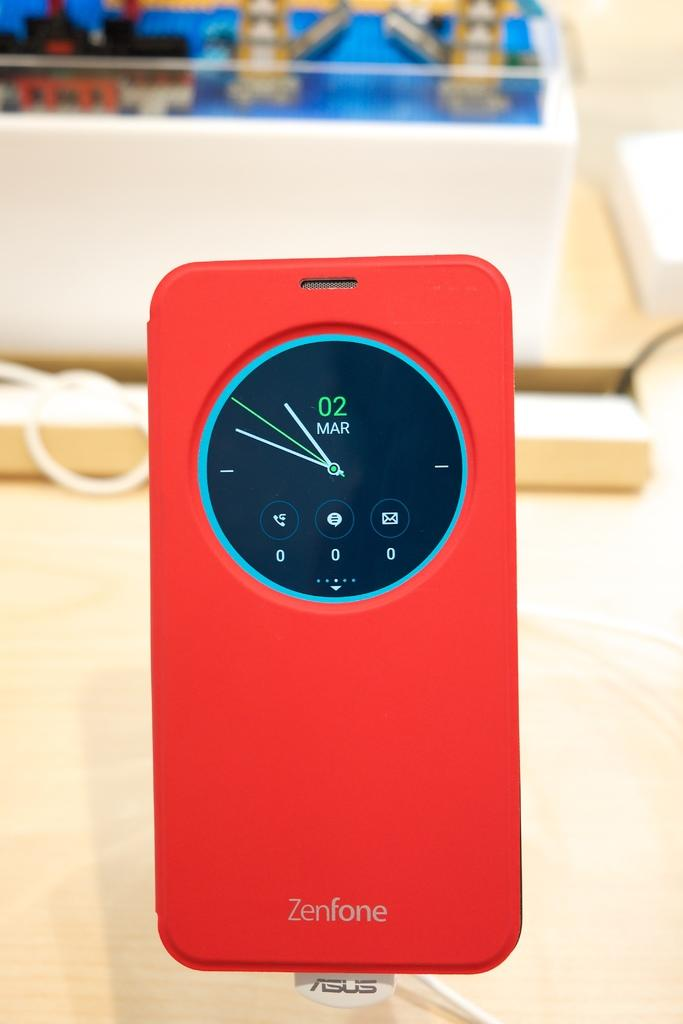Provide a one-sentence caption for the provided image. A red Zenfone case has clock on the back with the date March 2. 